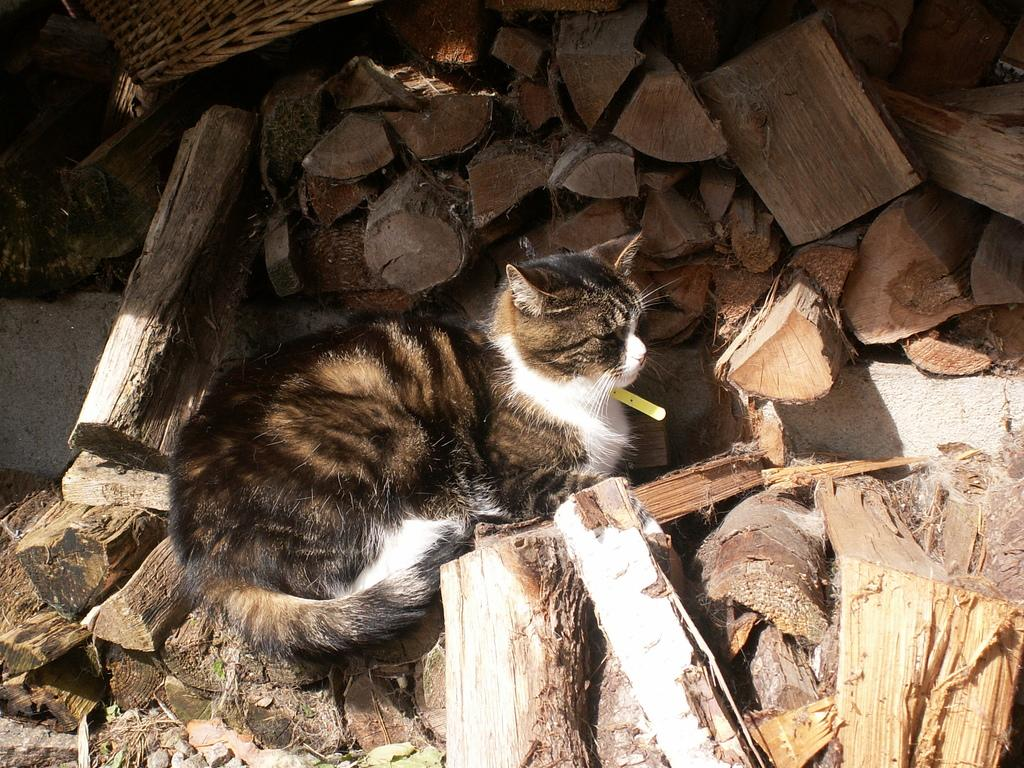What type of animal is in the image? There is a cat in the image. What is surrounding the cat in the image? There are wooden logs surrounding the cat. What type of destruction is the boy causing in the image? There is no boy present in the image, and therefore no destruction can be observed. 